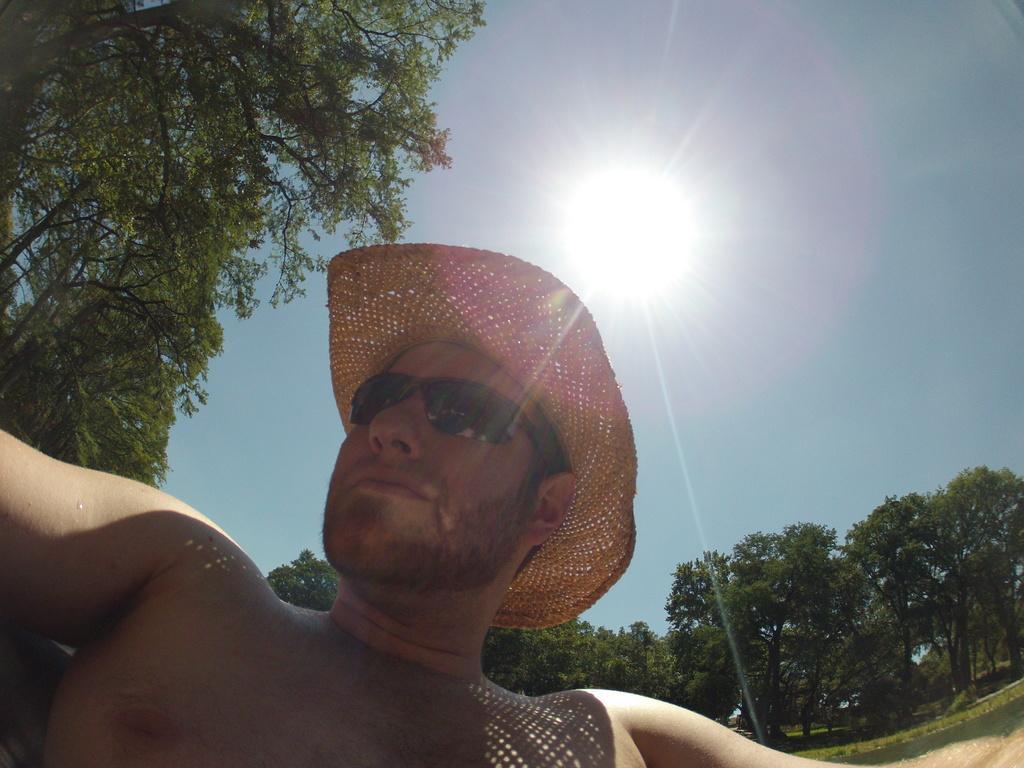Please provide a concise description of this image. In this image, we can see some trees. There is a person at the bottom of the image wearing sunglasses and hat. There is a sun in the sky. 